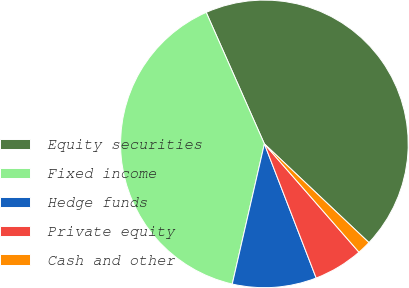Convert chart to OTSL. <chart><loc_0><loc_0><loc_500><loc_500><pie_chart><fcel>Equity securities<fcel>Fixed income<fcel>Hedge funds<fcel>Private equity<fcel>Cash and other<nl><fcel>43.67%<fcel>39.78%<fcel>9.45%<fcel>5.56%<fcel>1.53%<nl></chart> 